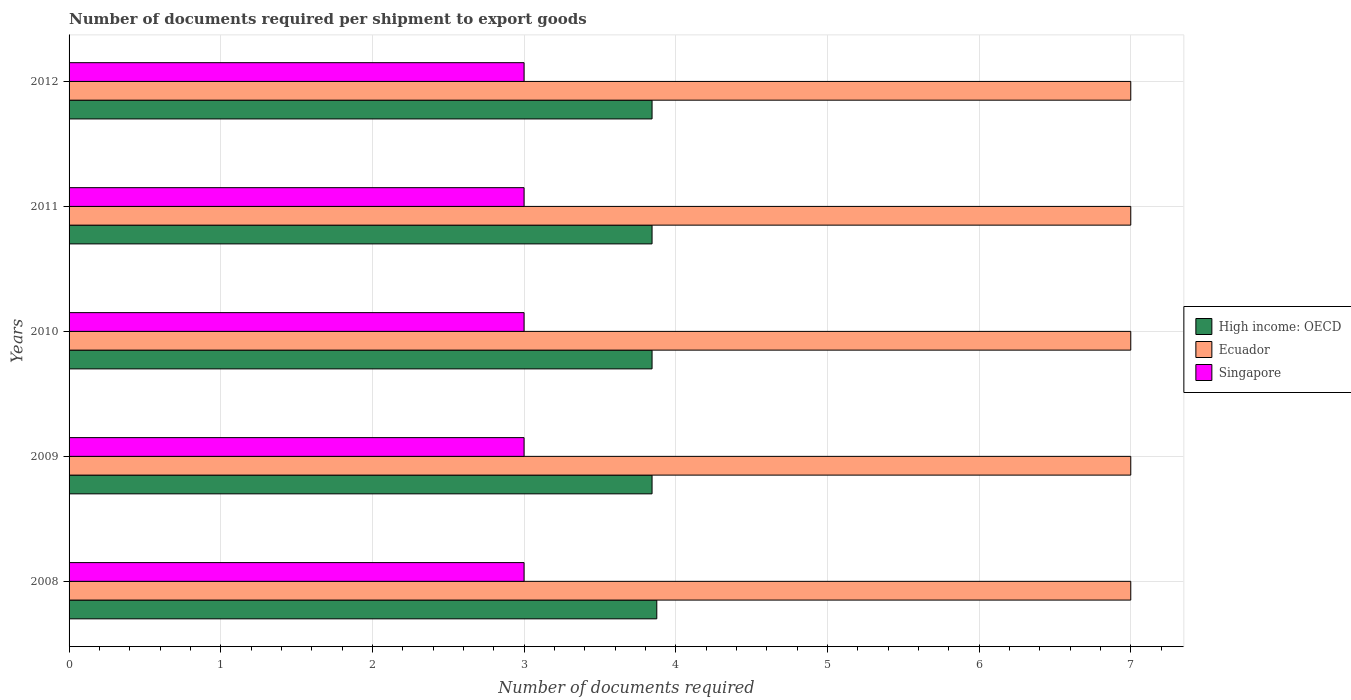Are the number of bars on each tick of the Y-axis equal?
Keep it short and to the point. Yes. How many bars are there on the 2nd tick from the top?
Provide a short and direct response. 3. How many bars are there on the 1st tick from the bottom?
Give a very brief answer. 3. What is the label of the 5th group of bars from the top?
Provide a short and direct response. 2008. What is the number of documents required per shipment to export goods in Singapore in 2008?
Offer a very short reply. 3. Across all years, what is the maximum number of documents required per shipment to export goods in High income: OECD?
Keep it short and to the point. 3.88. Across all years, what is the minimum number of documents required per shipment to export goods in Singapore?
Keep it short and to the point. 3. What is the total number of documents required per shipment to export goods in High income: OECD in the graph?
Give a very brief answer. 19.25. What is the difference between the number of documents required per shipment to export goods in Singapore in 2010 and that in 2012?
Make the answer very short. 0. What is the difference between the number of documents required per shipment to export goods in Ecuador in 2010 and the number of documents required per shipment to export goods in Singapore in 2012?
Provide a short and direct response. 4. What is the average number of documents required per shipment to export goods in High income: OECD per year?
Give a very brief answer. 3.85. In the year 2009, what is the difference between the number of documents required per shipment to export goods in Ecuador and number of documents required per shipment to export goods in Singapore?
Your response must be concise. 4. In how many years, is the number of documents required per shipment to export goods in Singapore greater than 4.4 ?
Make the answer very short. 0. What is the ratio of the number of documents required per shipment to export goods in Ecuador in 2008 to that in 2009?
Provide a short and direct response. 1. Is the number of documents required per shipment to export goods in Ecuador in 2010 less than that in 2011?
Provide a short and direct response. No. What is the difference between the highest and the second highest number of documents required per shipment to export goods in Singapore?
Ensure brevity in your answer.  0. What is the difference between the highest and the lowest number of documents required per shipment to export goods in High income: OECD?
Your response must be concise. 0.03. What does the 2nd bar from the top in 2011 represents?
Provide a short and direct response. Ecuador. What does the 2nd bar from the bottom in 2008 represents?
Offer a very short reply. Ecuador. How many bars are there?
Offer a terse response. 15. Are all the bars in the graph horizontal?
Your response must be concise. Yes. Are the values on the major ticks of X-axis written in scientific E-notation?
Keep it short and to the point. No. Does the graph contain grids?
Provide a succinct answer. Yes. How many legend labels are there?
Provide a succinct answer. 3. What is the title of the graph?
Keep it short and to the point. Number of documents required per shipment to export goods. Does "Indonesia" appear as one of the legend labels in the graph?
Your response must be concise. No. What is the label or title of the X-axis?
Your answer should be compact. Number of documents required. What is the label or title of the Y-axis?
Your response must be concise. Years. What is the Number of documents required in High income: OECD in 2008?
Give a very brief answer. 3.88. What is the Number of documents required in Ecuador in 2008?
Offer a very short reply. 7. What is the Number of documents required in Singapore in 2008?
Offer a very short reply. 3. What is the Number of documents required of High income: OECD in 2009?
Keep it short and to the point. 3.84. What is the Number of documents required of Ecuador in 2009?
Your response must be concise. 7. What is the Number of documents required in High income: OECD in 2010?
Keep it short and to the point. 3.84. What is the Number of documents required of Ecuador in 2010?
Ensure brevity in your answer.  7. What is the Number of documents required in Singapore in 2010?
Your answer should be compact. 3. What is the Number of documents required of High income: OECD in 2011?
Your response must be concise. 3.84. What is the Number of documents required in Singapore in 2011?
Make the answer very short. 3. What is the Number of documents required in High income: OECD in 2012?
Your response must be concise. 3.84. What is the Number of documents required of Ecuador in 2012?
Your response must be concise. 7. Across all years, what is the maximum Number of documents required of High income: OECD?
Give a very brief answer. 3.88. Across all years, what is the maximum Number of documents required in Ecuador?
Provide a short and direct response. 7. Across all years, what is the maximum Number of documents required of Singapore?
Make the answer very short. 3. Across all years, what is the minimum Number of documents required in High income: OECD?
Your answer should be very brief. 3.84. Across all years, what is the minimum Number of documents required in Ecuador?
Keep it short and to the point. 7. What is the total Number of documents required in High income: OECD in the graph?
Keep it short and to the point. 19.25. What is the total Number of documents required of Ecuador in the graph?
Offer a terse response. 35. What is the difference between the Number of documents required in High income: OECD in 2008 and that in 2009?
Offer a very short reply. 0.03. What is the difference between the Number of documents required in Ecuador in 2008 and that in 2009?
Provide a succinct answer. 0. What is the difference between the Number of documents required in High income: OECD in 2008 and that in 2010?
Keep it short and to the point. 0.03. What is the difference between the Number of documents required of Ecuador in 2008 and that in 2010?
Offer a terse response. 0. What is the difference between the Number of documents required of Singapore in 2008 and that in 2010?
Provide a short and direct response. 0. What is the difference between the Number of documents required in High income: OECD in 2008 and that in 2011?
Your answer should be compact. 0.03. What is the difference between the Number of documents required in Ecuador in 2008 and that in 2011?
Your response must be concise. 0. What is the difference between the Number of documents required of Singapore in 2008 and that in 2011?
Offer a very short reply. 0. What is the difference between the Number of documents required of High income: OECD in 2008 and that in 2012?
Provide a succinct answer. 0.03. What is the difference between the Number of documents required of Ecuador in 2008 and that in 2012?
Your response must be concise. 0. What is the difference between the Number of documents required of Singapore in 2009 and that in 2010?
Provide a succinct answer. 0. What is the difference between the Number of documents required in High income: OECD in 2009 and that in 2012?
Give a very brief answer. 0. What is the difference between the Number of documents required in Singapore in 2009 and that in 2012?
Keep it short and to the point. 0. What is the difference between the Number of documents required in Ecuador in 2010 and that in 2011?
Offer a terse response. 0. What is the difference between the Number of documents required of High income: OECD in 2010 and that in 2012?
Make the answer very short. 0. What is the difference between the Number of documents required in Ecuador in 2010 and that in 2012?
Give a very brief answer. 0. What is the difference between the Number of documents required of Singapore in 2010 and that in 2012?
Offer a very short reply. 0. What is the difference between the Number of documents required in High income: OECD in 2011 and that in 2012?
Offer a very short reply. 0. What is the difference between the Number of documents required in Singapore in 2011 and that in 2012?
Provide a succinct answer. 0. What is the difference between the Number of documents required of High income: OECD in 2008 and the Number of documents required of Ecuador in 2009?
Make the answer very short. -3.12. What is the difference between the Number of documents required in High income: OECD in 2008 and the Number of documents required in Singapore in 2009?
Provide a short and direct response. 0.88. What is the difference between the Number of documents required of High income: OECD in 2008 and the Number of documents required of Ecuador in 2010?
Give a very brief answer. -3.12. What is the difference between the Number of documents required in High income: OECD in 2008 and the Number of documents required in Singapore in 2010?
Offer a terse response. 0.88. What is the difference between the Number of documents required in Ecuador in 2008 and the Number of documents required in Singapore in 2010?
Keep it short and to the point. 4. What is the difference between the Number of documents required of High income: OECD in 2008 and the Number of documents required of Ecuador in 2011?
Make the answer very short. -3.12. What is the difference between the Number of documents required in High income: OECD in 2008 and the Number of documents required in Singapore in 2011?
Make the answer very short. 0.88. What is the difference between the Number of documents required in High income: OECD in 2008 and the Number of documents required in Ecuador in 2012?
Your response must be concise. -3.12. What is the difference between the Number of documents required in High income: OECD in 2008 and the Number of documents required in Singapore in 2012?
Ensure brevity in your answer.  0.88. What is the difference between the Number of documents required in Ecuador in 2008 and the Number of documents required in Singapore in 2012?
Your answer should be very brief. 4. What is the difference between the Number of documents required in High income: OECD in 2009 and the Number of documents required in Ecuador in 2010?
Offer a very short reply. -3.16. What is the difference between the Number of documents required in High income: OECD in 2009 and the Number of documents required in Singapore in 2010?
Your answer should be very brief. 0.84. What is the difference between the Number of documents required in Ecuador in 2009 and the Number of documents required in Singapore in 2010?
Ensure brevity in your answer.  4. What is the difference between the Number of documents required of High income: OECD in 2009 and the Number of documents required of Ecuador in 2011?
Provide a short and direct response. -3.16. What is the difference between the Number of documents required of High income: OECD in 2009 and the Number of documents required of Singapore in 2011?
Your response must be concise. 0.84. What is the difference between the Number of documents required in High income: OECD in 2009 and the Number of documents required in Ecuador in 2012?
Offer a very short reply. -3.16. What is the difference between the Number of documents required in High income: OECD in 2009 and the Number of documents required in Singapore in 2012?
Your response must be concise. 0.84. What is the difference between the Number of documents required in Ecuador in 2009 and the Number of documents required in Singapore in 2012?
Your answer should be compact. 4. What is the difference between the Number of documents required in High income: OECD in 2010 and the Number of documents required in Ecuador in 2011?
Make the answer very short. -3.16. What is the difference between the Number of documents required in High income: OECD in 2010 and the Number of documents required in Singapore in 2011?
Keep it short and to the point. 0.84. What is the difference between the Number of documents required in Ecuador in 2010 and the Number of documents required in Singapore in 2011?
Your answer should be very brief. 4. What is the difference between the Number of documents required in High income: OECD in 2010 and the Number of documents required in Ecuador in 2012?
Ensure brevity in your answer.  -3.16. What is the difference between the Number of documents required in High income: OECD in 2010 and the Number of documents required in Singapore in 2012?
Keep it short and to the point. 0.84. What is the difference between the Number of documents required of Ecuador in 2010 and the Number of documents required of Singapore in 2012?
Offer a very short reply. 4. What is the difference between the Number of documents required in High income: OECD in 2011 and the Number of documents required in Ecuador in 2012?
Provide a short and direct response. -3.16. What is the difference between the Number of documents required in High income: OECD in 2011 and the Number of documents required in Singapore in 2012?
Your answer should be compact. 0.84. What is the average Number of documents required of High income: OECD per year?
Ensure brevity in your answer.  3.85. In the year 2008, what is the difference between the Number of documents required in High income: OECD and Number of documents required in Ecuador?
Provide a short and direct response. -3.12. In the year 2009, what is the difference between the Number of documents required of High income: OECD and Number of documents required of Ecuador?
Offer a very short reply. -3.16. In the year 2009, what is the difference between the Number of documents required in High income: OECD and Number of documents required in Singapore?
Provide a succinct answer. 0.84. In the year 2009, what is the difference between the Number of documents required of Ecuador and Number of documents required of Singapore?
Keep it short and to the point. 4. In the year 2010, what is the difference between the Number of documents required in High income: OECD and Number of documents required in Ecuador?
Provide a succinct answer. -3.16. In the year 2010, what is the difference between the Number of documents required of High income: OECD and Number of documents required of Singapore?
Provide a succinct answer. 0.84. In the year 2010, what is the difference between the Number of documents required in Ecuador and Number of documents required in Singapore?
Your response must be concise. 4. In the year 2011, what is the difference between the Number of documents required in High income: OECD and Number of documents required in Ecuador?
Your response must be concise. -3.16. In the year 2011, what is the difference between the Number of documents required of High income: OECD and Number of documents required of Singapore?
Ensure brevity in your answer.  0.84. In the year 2012, what is the difference between the Number of documents required in High income: OECD and Number of documents required in Ecuador?
Offer a terse response. -3.16. In the year 2012, what is the difference between the Number of documents required in High income: OECD and Number of documents required in Singapore?
Provide a short and direct response. 0.84. In the year 2012, what is the difference between the Number of documents required of Ecuador and Number of documents required of Singapore?
Offer a terse response. 4. What is the ratio of the Number of documents required in Ecuador in 2008 to that in 2009?
Offer a very short reply. 1. What is the ratio of the Number of documents required of Ecuador in 2008 to that in 2010?
Offer a very short reply. 1. What is the ratio of the Number of documents required in Singapore in 2008 to that in 2010?
Your response must be concise. 1. What is the ratio of the Number of documents required of High income: OECD in 2008 to that in 2011?
Ensure brevity in your answer.  1.01. What is the ratio of the Number of documents required in Singapore in 2008 to that in 2011?
Offer a very short reply. 1. What is the ratio of the Number of documents required in Singapore in 2008 to that in 2012?
Make the answer very short. 1. What is the ratio of the Number of documents required in High income: OECD in 2009 to that in 2010?
Keep it short and to the point. 1. What is the ratio of the Number of documents required of Singapore in 2009 to that in 2010?
Make the answer very short. 1. What is the ratio of the Number of documents required in Ecuador in 2009 to that in 2011?
Your answer should be very brief. 1. What is the ratio of the Number of documents required of High income: OECD in 2009 to that in 2012?
Your answer should be very brief. 1. What is the ratio of the Number of documents required of Ecuador in 2010 to that in 2011?
Your answer should be compact. 1. What is the ratio of the Number of documents required of Singapore in 2010 to that in 2011?
Ensure brevity in your answer.  1. What is the ratio of the Number of documents required of High income: OECD in 2011 to that in 2012?
Make the answer very short. 1. What is the ratio of the Number of documents required in Ecuador in 2011 to that in 2012?
Offer a terse response. 1. What is the ratio of the Number of documents required of Singapore in 2011 to that in 2012?
Your answer should be very brief. 1. What is the difference between the highest and the second highest Number of documents required in High income: OECD?
Your response must be concise. 0.03. What is the difference between the highest and the second highest Number of documents required of Singapore?
Your answer should be compact. 0. What is the difference between the highest and the lowest Number of documents required of High income: OECD?
Give a very brief answer. 0.03. 